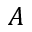<formula> <loc_0><loc_0><loc_500><loc_500>A</formula> 